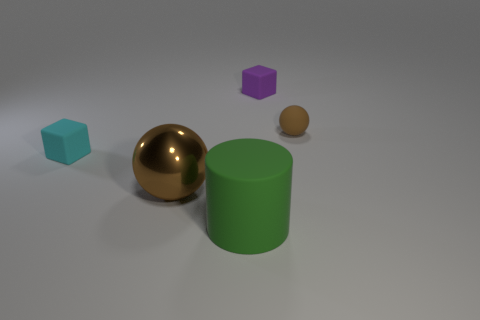Add 2 cyan matte cubes. How many objects exist? 7 Subtract all cylinders. How many objects are left? 4 Subtract all big gray rubber balls. Subtract all brown objects. How many objects are left? 3 Add 2 large brown balls. How many large brown balls are left? 3 Add 2 matte cylinders. How many matte cylinders exist? 3 Subtract 0 purple cylinders. How many objects are left? 5 